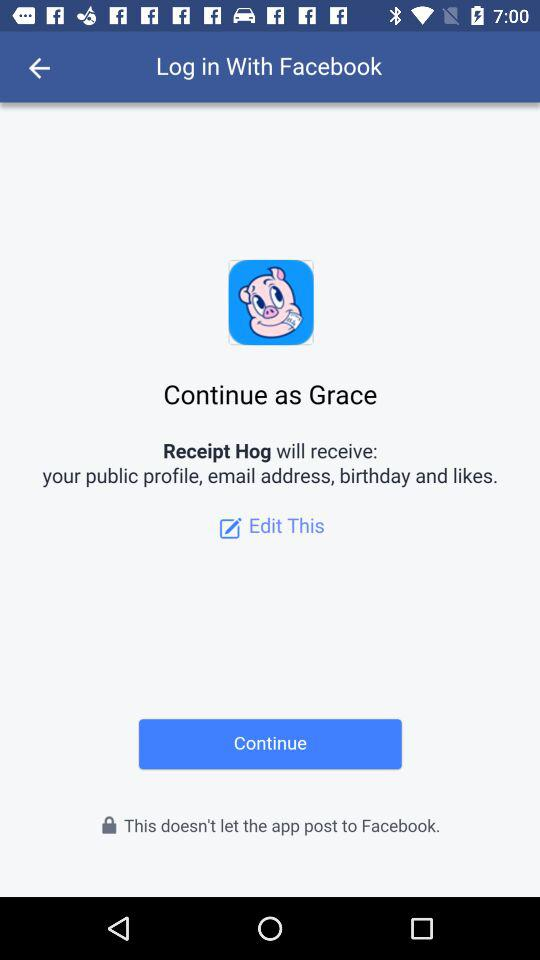What application can be used to log in? The application that can be used to log in is "Facebook". 